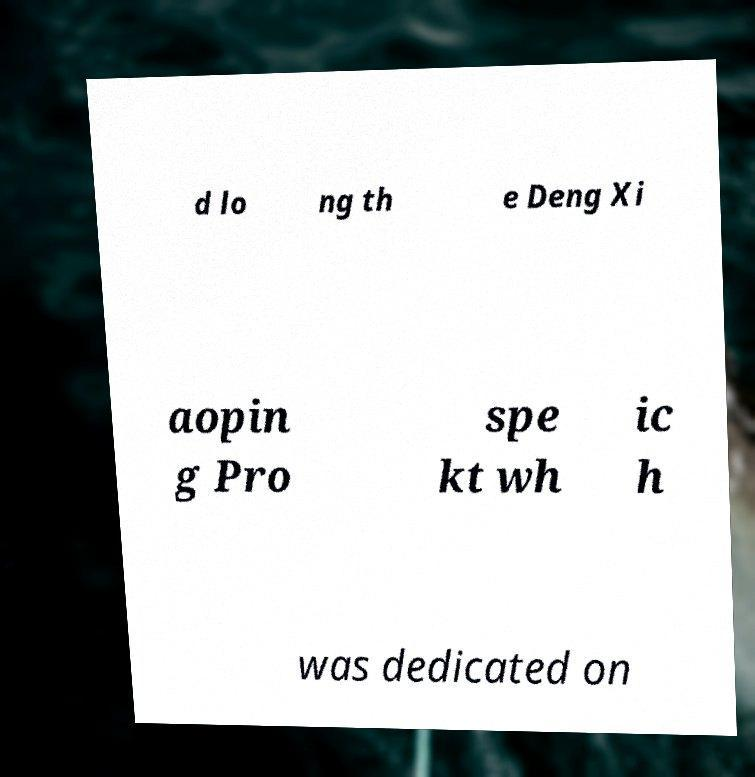What messages or text are displayed in this image? I need them in a readable, typed format. d lo ng th e Deng Xi aopin g Pro spe kt wh ic h was dedicated on 